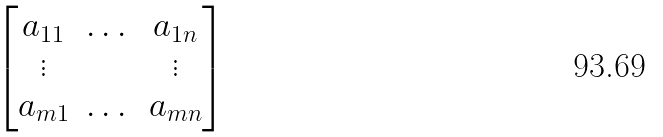Convert formula to latex. <formula><loc_0><loc_0><loc_500><loc_500>\begin{bmatrix} a _ { 1 1 } & \dots & a _ { 1 n } \\ \vdots & & \vdots \\ a _ { m 1 } & \dots & a _ { m n } \end{bmatrix}</formula> 